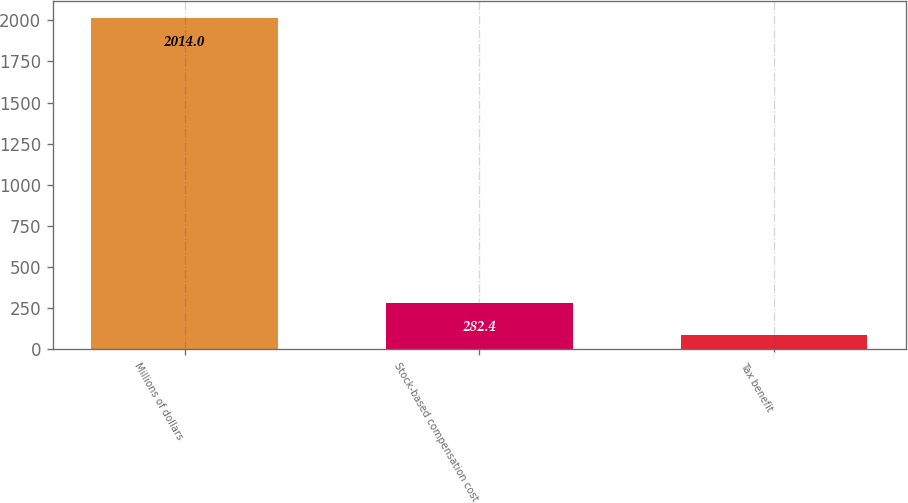Convert chart. <chart><loc_0><loc_0><loc_500><loc_500><bar_chart><fcel>Millions of dollars<fcel>Stock-based compensation cost<fcel>Tax benefit<nl><fcel>2014<fcel>282.4<fcel>90<nl></chart> 